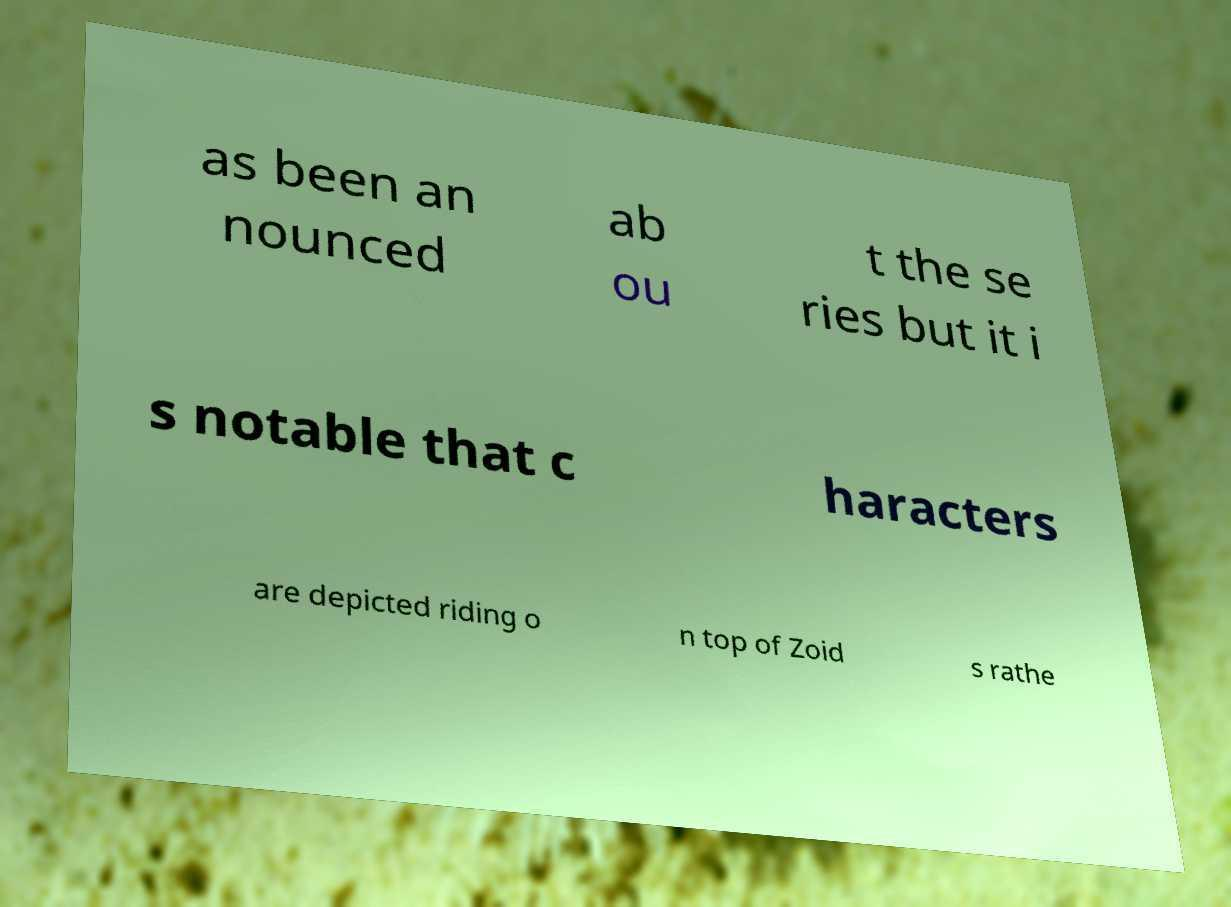Can you accurately transcribe the text from the provided image for me? as been an nounced ab ou t the se ries but it i s notable that c haracters are depicted riding o n top of Zoid s rathe 